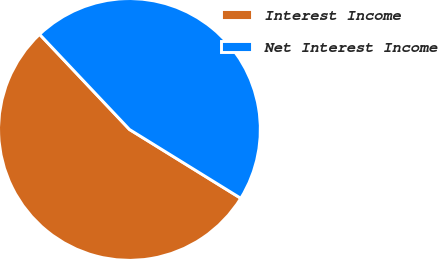Convert chart. <chart><loc_0><loc_0><loc_500><loc_500><pie_chart><fcel>Interest Income<fcel>Net Interest Income<nl><fcel>54.14%<fcel>45.86%<nl></chart> 